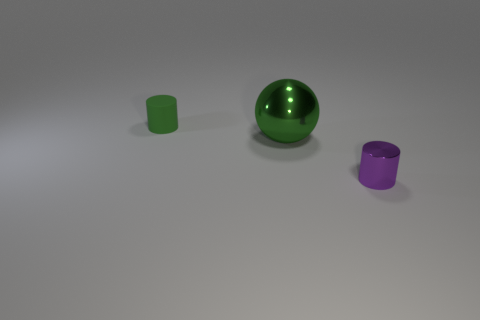Is there any other thing that is the same size as the shiny ball?
Your answer should be very brief. No. What number of other objects are the same color as the small shiny thing?
Provide a succinct answer. 0. Does the tiny object behind the small metal thing have the same material as the tiny cylinder in front of the large thing?
Make the answer very short. No. Are there the same number of tiny rubber cylinders that are in front of the small matte object and tiny green objects that are right of the metal cylinder?
Provide a succinct answer. Yes. What is the material of the green object to the right of the small rubber object?
Your response must be concise. Metal. Is the number of tiny blue blocks less than the number of green things?
Provide a succinct answer. Yes. There is a thing that is both in front of the rubber cylinder and left of the purple metallic thing; what is its shape?
Give a very brief answer. Sphere. How many small cylinders are there?
Provide a succinct answer. 2. The large green object on the left side of the small object right of the cylinder that is behind the purple object is made of what material?
Provide a succinct answer. Metal. What number of large spheres are behind the big green shiny sphere in front of the green rubber thing?
Offer a terse response. 0. 